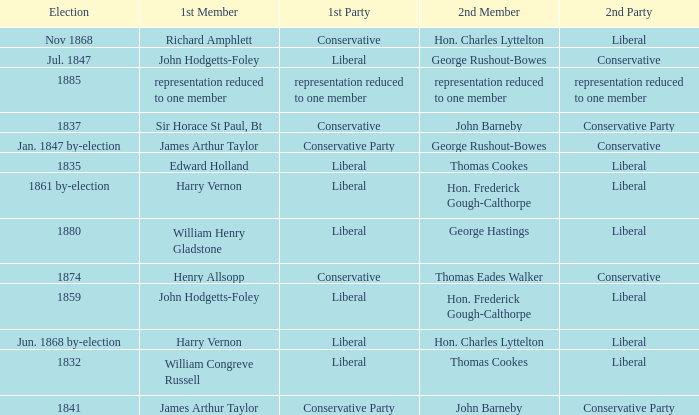What was the 2nd Party that had the 2nd Member John Barneby, when the 1st Party was Conservative? Conservative Party. 